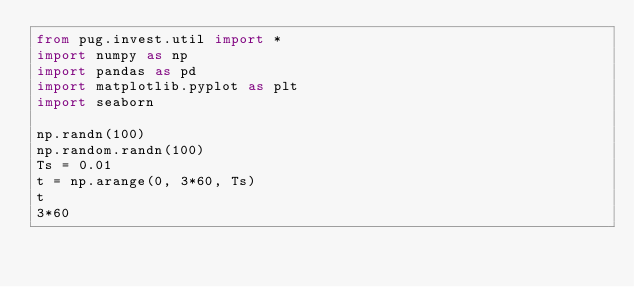Convert code to text. <code><loc_0><loc_0><loc_500><loc_500><_Python_>from pug.invest.util import *
import numpy as np
import pandas as pd
import matplotlib.pyplot as plt
import seaborn

np.randn(100)
np.random.randn(100)
Ts = 0.01
t = np.arange(0, 3*60, Ts)
t
3*60</code> 